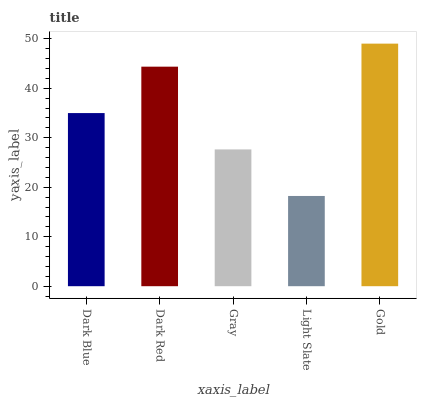Is Light Slate the minimum?
Answer yes or no. Yes. Is Gold the maximum?
Answer yes or no. Yes. Is Dark Red the minimum?
Answer yes or no. No. Is Dark Red the maximum?
Answer yes or no. No. Is Dark Red greater than Dark Blue?
Answer yes or no. Yes. Is Dark Blue less than Dark Red?
Answer yes or no. Yes. Is Dark Blue greater than Dark Red?
Answer yes or no. No. Is Dark Red less than Dark Blue?
Answer yes or no. No. Is Dark Blue the high median?
Answer yes or no. Yes. Is Dark Blue the low median?
Answer yes or no. Yes. Is Dark Red the high median?
Answer yes or no. No. Is Light Slate the low median?
Answer yes or no. No. 